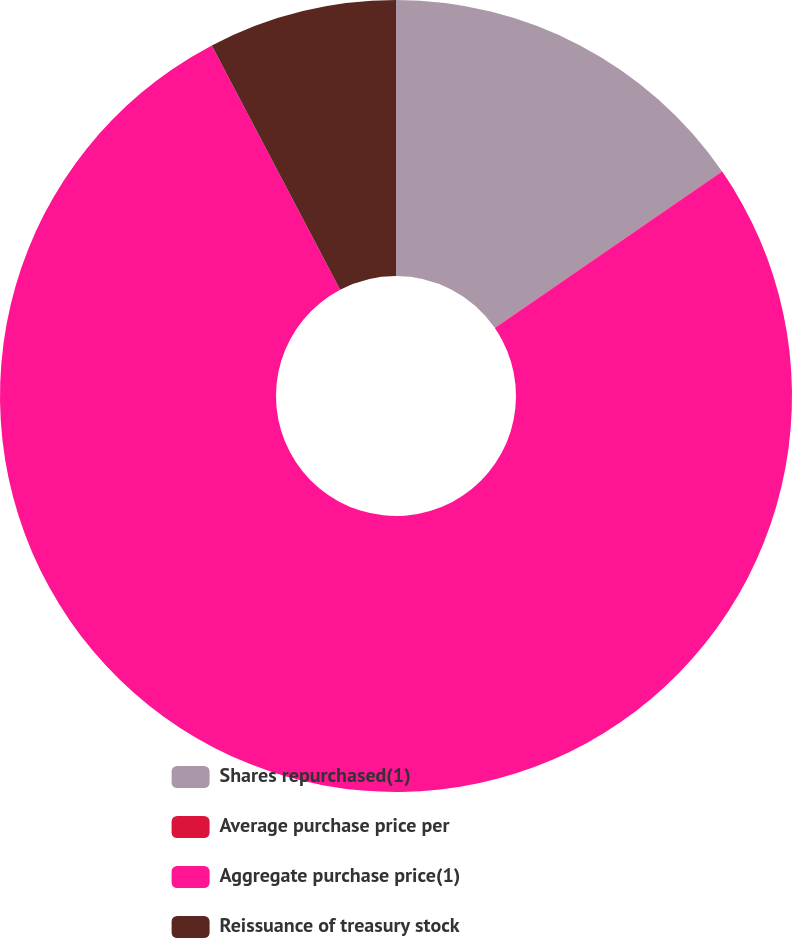<chart> <loc_0><loc_0><loc_500><loc_500><pie_chart><fcel>Shares repurchased(1)<fcel>Average purchase price per<fcel>Aggregate purchase price(1)<fcel>Reissuance of treasury stock<nl><fcel>15.39%<fcel>0.02%<fcel>76.89%<fcel>7.7%<nl></chart> 